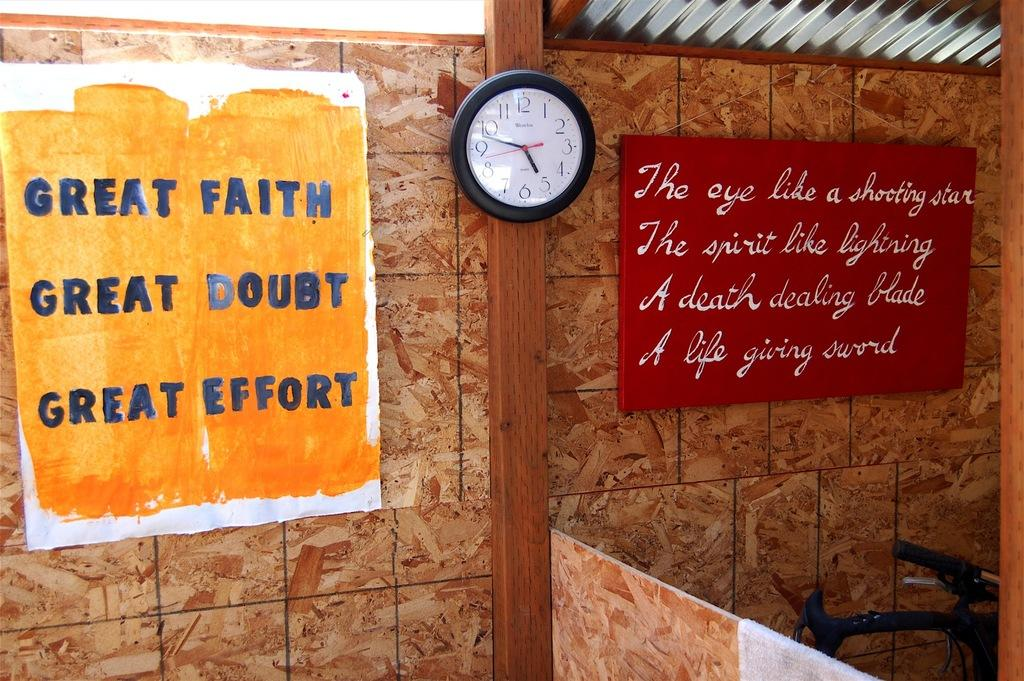<image>
Share a concise interpretation of the image provided. A sign on the wall that says Great Effort. 